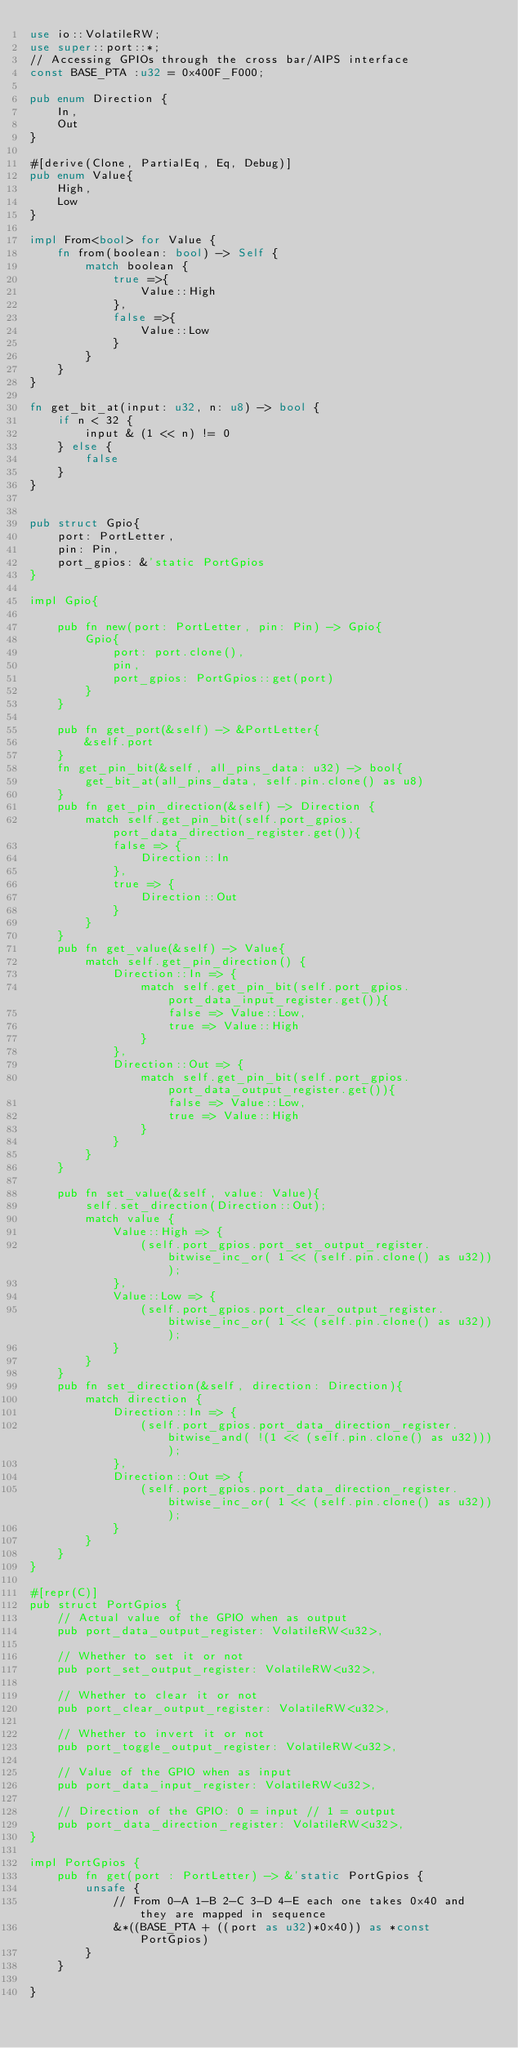Convert code to text. <code><loc_0><loc_0><loc_500><loc_500><_Rust_>use io::VolatileRW;
use super::port::*;
// Accessing GPIOs through the cross bar/AIPS interface
const BASE_PTA :u32 = 0x400F_F000;

pub enum Direction {
    In,
    Out
}

#[derive(Clone, PartialEq, Eq, Debug)]
pub enum Value{
    High,
    Low
}

impl From<bool> for Value {
    fn from(boolean: bool) -> Self {
        match boolean {
            true =>{
                Value::High
            },
            false =>{
                Value::Low
            }
        }
    }
}

fn get_bit_at(input: u32, n: u8) -> bool {
    if n < 32 {
        input & (1 << n) != 0
    } else {
        false
    }
}


pub struct Gpio{
    port: PortLetter,
    pin: Pin,
    port_gpios: &'static PortGpios
}

impl Gpio{

    pub fn new(port: PortLetter, pin: Pin) -> Gpio{
        Gpio{
            port: port.clone(),
            pin,
            port_gpios: PortGpios::get(port)
        }
    }

    pub fn get_port(&self) -> &PortLetter{
        &self.port
    }
    fn get_pin_bit(&self, all_pins_data: u32) -> bool{
        get_bit_at(all_pins_data, self.pin.clone() as u8)
    }
    pub fn get_pin_direction(&self) -> Direction {
        match self.get_pin_bit(self.port_gpios.port_data_direction_register.get()){
            false => {
                Direction::In
            },
            true => {
                Direction::Out
            }
        }
    }
    pub fn get_value(&self) -> Value{
        match self.get_pin_direction() {
            Direction::In => {
                match self.get_pin_bit(self.port_gpios.port_data_input_register.get()){
                    false => Value::Low,
                    true => Value::High
                }
            },
            Direction::Out => {
                match self.get_pin_bit(self.port_gpios.port_data_output_register.get()){
                    false => Value::Low,
                    true => Value::High
                }
            }
        }
    }

    pub fn set_value(&self, value: Value){
        self.set_direction(Direction::Out);
        match value {
            Value::High => {
                (self.port_gpios.port_set_output_register.bitwise_inc_or( 1 << (self.pin.clone() as u32)));
            },
            Value::Low => {
                (self.port_gpios.port_clear_output_register.bitwise_inc_or( 1 << (self.pin.clone() as u32)));
            }
        }
    }
    pub fn set_direction(&self, direction: Direction){
        match direction {
            Direction::In => {
                (self.port_gpios.port_data_direction_register.bitwise_and( !(1 << (self.pin.clone() as u32))));
            },
            Direction::Out => {
                (self.port_gpios.port_data_direction_register.bitwise_inc_or( 1 << (self.pin.clone() as u32)));
            }
        }
    }
}

#[repr(C)]
pub struct PortGpios {
    // Actual value of the GPIO when as output
    pub port_data_output_register: VolatileRW<u32>,

    // Whether to set it or not
    pub port_set_output_register: VolatileRW<u32>,

    // Whether to clear it or not
    pub port_clear_output_register: VolatileRW<u32>,

    // Whether to invert it or not
    pub port_toggle_output_register: VolatileRW<u32>,

    // Value of the GPIO when as input
    pub port_data_input_register: VolatileRW<u32>,

    // Direction of the GPIO: 0 = input // 1 = output
    pub port_data_direction_register: VolatileRW<u32>,
}

impl PortGpios {
    pub fn get(port : PortLetter) -> &'static PortGpios {
        unsafe {
            // From 0-A 1-B 2-C 3-D 4-E each one takes 0x40 and they are mapped in sequence
            &*((BASE_PTA + ((port as u32)*0x40)) as *const PortGpios)
        }
    }

}

</code> 